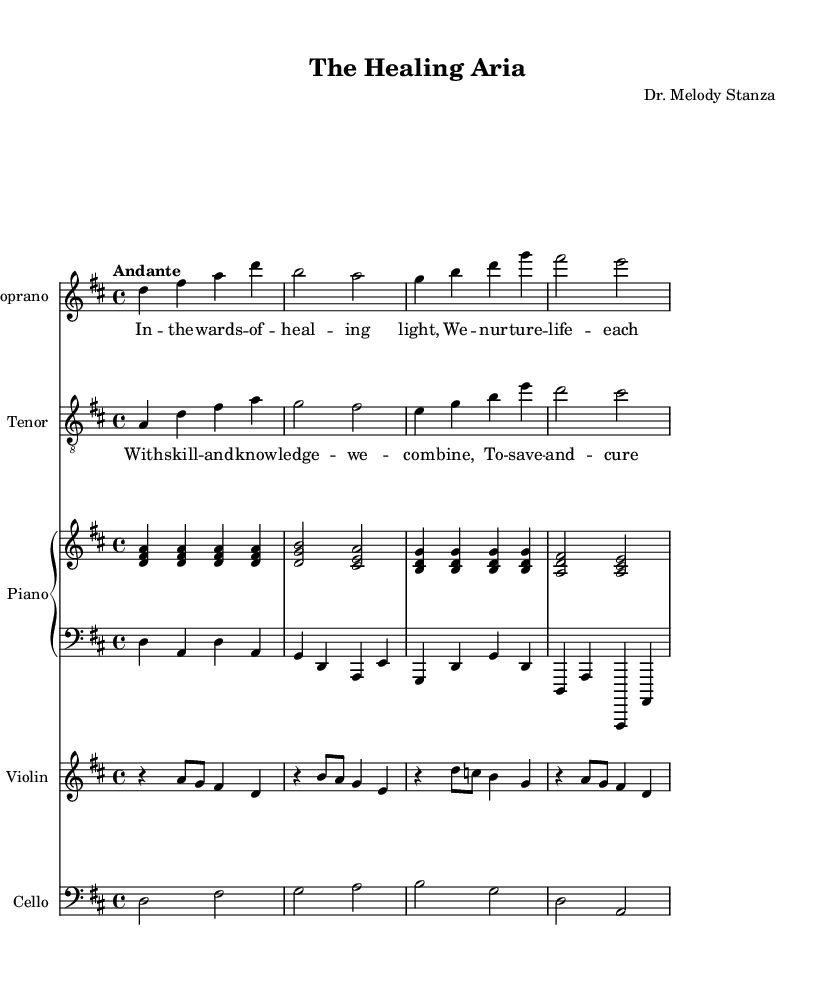What is the key signature of this music? The key signature is D major, which has two sharps, F# and C#. This can be identified at the beginning of the sheet music where the sharps are placed.
Answer: D major What is the time signature of this music? The time signature is 4/4, which indicates there are four beats in each measure, and a quarter note receives one beat. This is clearly stated at the beginning of the score.
Answer: 4/4 What is the tempo marking of the music? The tempo marking is "Andante," which suggests a moderately slow tempo. This marking is found above the staves at the beginning of the piece.
Answer: Andante How many measures are in the soprano part? The soprano part consists of four measures, which can be seen by counting the vertical bar lines that separate the measures in the staff.
Answer: Four What is the starting note of the tenor part? The starting note of the tenor part is A. This can be identified by looking at the first note in the tenor staff, which is notated at the beginning of the score.
Answer: A What is the relationship between the soprano and tenor parts? The soprano and tenor parts are harmonizing, as they sing different melodies that complement each other. This can be observed as both parts progress together throughout the piece, creating a rich vocal texture.
Answer: Harmonizing What role do the medical professionals play in the opera's narrative? The medical professionals are depicted as caregivers who nurture life and contribute to healing, as expressed in the lyrics of the soprano and tenor parts. The lyrics emphasize themes of skill, knowledge, and dedication to saving lives.
Answer: Caregivers 